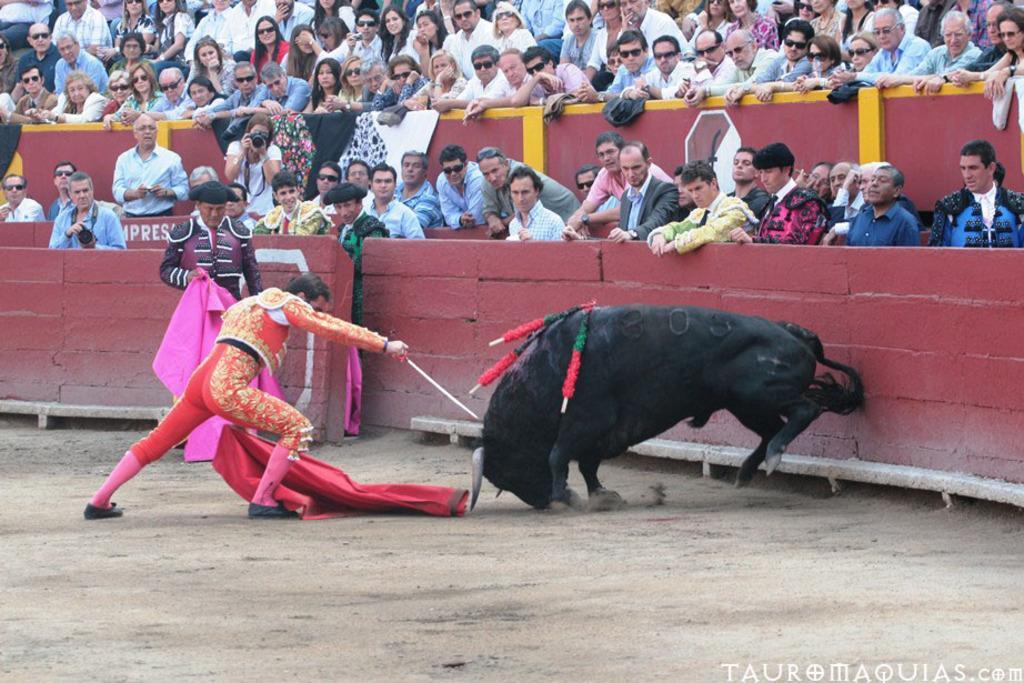In one or two sentences, can you explain what this image depicts? In this image in the center there is bull and one man who is holding a red color cloth and a stick, and in the background there are a group of people who are sitting and watching and some of them are holding cameras and some other things. At the bottom there is sand and also there is wall. 